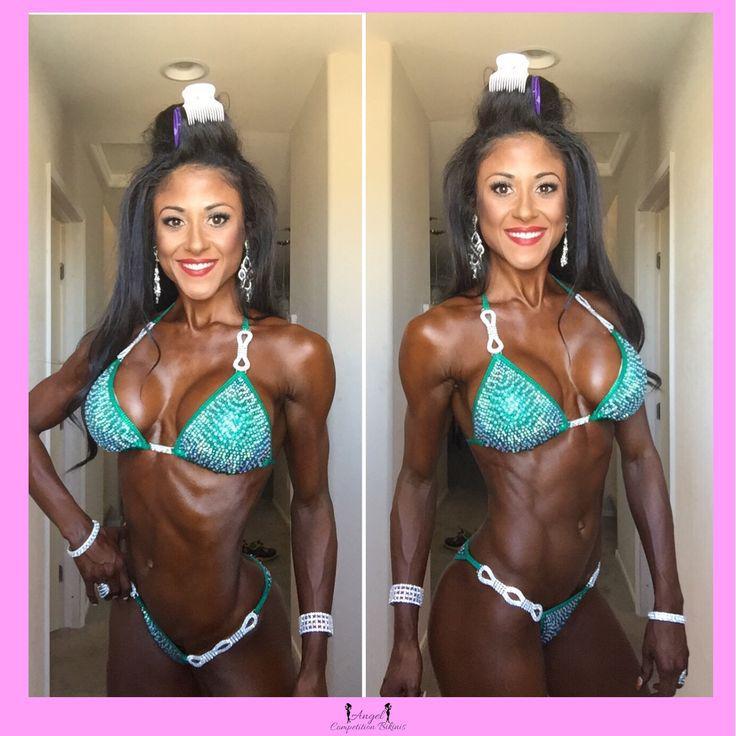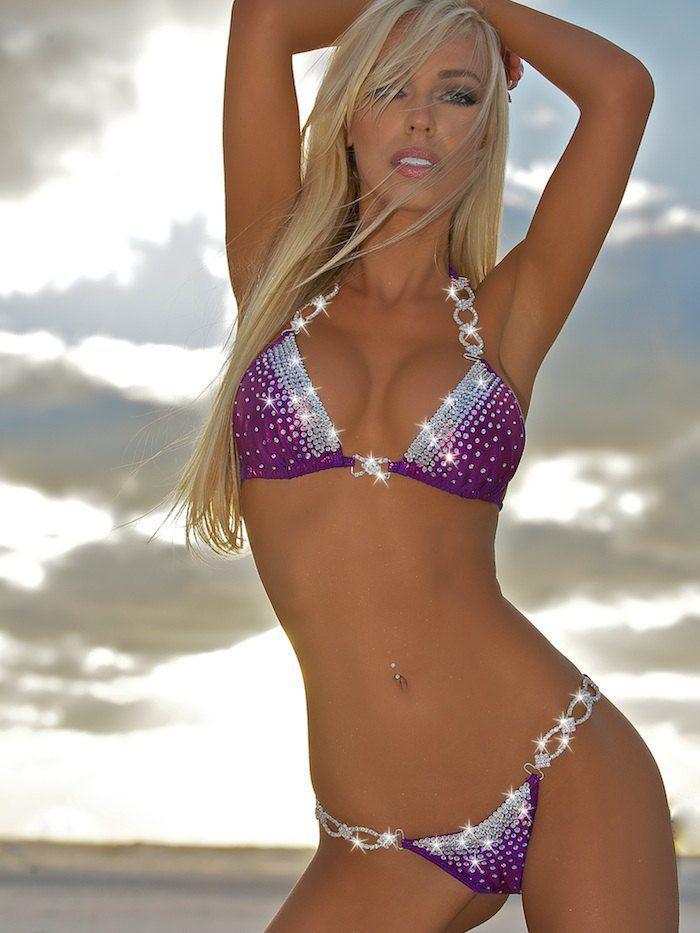The first image is the image on the left, the second image is the image on the right. For the images displayed, is the sentence "In at least one image there are at least two identical women in blue bikinis." factually correct? Answer yes or no. Yes. The first image is the image on the left, the second image is the image on the right. Assess this claim about the two images: "A single blonde woman is wearing a bikini in one of the images.". Correct or not? Answer yes or no. Yes. 